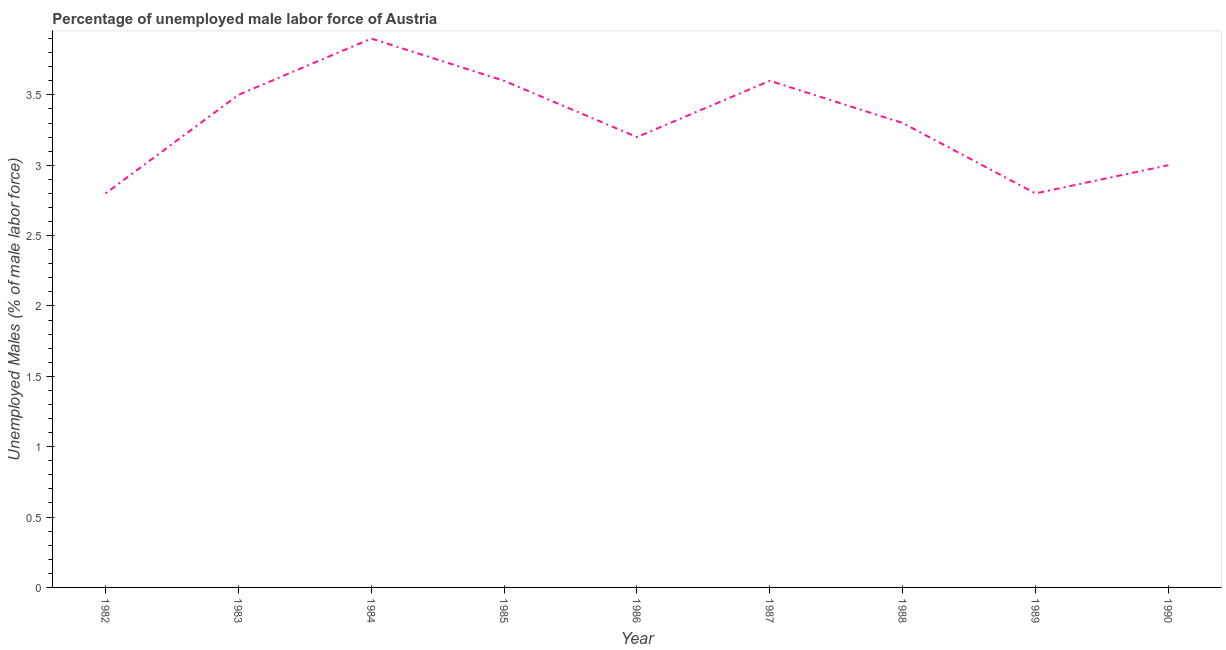What is the total unemployed male labour force in 1989?
Ensure brevity in your answer.  2.8. Across all years, what is the maximum total unemployed male labour force?
Your answer should be very brief. 3.9. Across all years, what is the minimum total unemployed male labour force?
Offer a terse response. 2.8. What is the sum of the total unemployed male labour force?
Provide a short and direct response. 29.7. What is the difference between the total unemployed male labour force in 1982 and 1986?
Give a very brief answer. -0.4. What is the average total unemployed male labour force per year?
Offer a terse response. 3.3. What is the median total unemployed male labour force?
Offer a very short reply. 3.3. In how many years, is the total unemployed male labour force greater than 0.6 %?
Ensure brevity in your answer.  9. Do a majority of the years between 1990 and 1982 (inclusive) have total unemployed male labour force greater than 1.4 %?
Keep it short and to the point. Yes. What is the ratio of the total unemployed male labour force in 1982 to that in 1983?
Provide a short and direct response. 0.8. Is the total unemployed male labour force in 1986 less than that in 1989?
Your response must be concise. No. Is the difference between the total unemployed male labour force in 1982 and 1989 greater than the difference between any two years?
Provide a short and direct response. No. What is the difference between the highest and the second highest total unemployed male labour force?
Offer a very short reply. 0.3. What is the difference between the highest and the lowest total unemployed male labour force?
Offer a very short reply. 1.1. Does the total unemployed male labour force monotonically increase over the years?
Make the answer very short. No. What is the difference between two consecutive major ticks on the Y-axis?
Provide a short and direct response. 0.5. Are the values on the major ticks of Y-axis written in scientific E-notation?
Make the answer very short. No. Does the graph contain grids?
Your answer should be compact. No. What is the title of the graph?
Provide a short and direct response. Percentage of unemployed male labor force of Austria. What is the label or title of the Y-axis?
Your answer should be very brief. Unemployed Males (% of male labor force). What is the Unemployed Males (% of male labor force) of 1982?
Keep it short and to the point. 2.8. What is the Unemployed Males (% of male labor force) in 1984?
Provide a succinct answer. 3.9. What is the Unemployed Males (% of male labor force) in 1985?
Keep it short and to the point. 3.6. What is the Unemployed Males (% of male labor force) of 1986?
Keep it short and to the point. 3.2. What is the Unemployed Males (% of male labor force) of 1987?
Provide a succinct answer. 3.6. What is the Unemployed Males (% of male labor force) in 1988?
Your response must be concise. 3.3. What is the Unemployed Males (% of male labor force) of 1989?
Make the answer very short. 2.8. What is the Unemployed Males (% of male labor force) in 1990?
Offer a terse response. 3. What is the difference between the Unemployed Males (% of male labor force) in 1982 and 1983?
Provide a succinct answer. -0.7. What is the difference between the Unemployed Males (% of male labor force) in 1982 and 1984?
Offer a terse response. -1.1. What is the difference between the Unemployed Males (% of male labor force) in 1982 and 1985?
Keep it short and to the point. -0.8. What is the difference between the Unemployed Males (% of male labor force) in 1982 and 1988?
Offer a terse response. -0.5. What is the difference between the Unemployed Males (% of male labor force) in 1982 and 1990?
Make the answer very short. -0.2. What is the difference between the Unemployed Males (% of male labor force) in 1983 and 1984?
Provide a succinct answer. -0.4. What is the difference between the Unemployed Males (% of male labor force) in 1983 and 1985?
Give a very brief answer. -0.1. What is the difference between the Unemployed Males (% of male labor force) in 1983 and 1986?
Ensure brevity in your answer.  0.3. What is the difference between the Unemployed Males (% of male labor force) in 1983 and 1987?
Provide a short and direct response. -0.1. What is the difference between the Unemployed Males (% of male labor force) in 1983 and 1988?
Provide a succinct answer. 0.2. What is the difference between the Unemployed Males (% of male labor force) in 1983 and 1989?
Your response must be concise. 0.7. What is the difference between the Unemployed Males (% of male labor force) in 1983 and 1990?
Offer a very short reply. 0.5. What is the difference between the Unemployed Males (% of male labor force) in 1984 and 1987?
Give a very brief answer. 0.3. What is the difference between the Unemployed Males (% of male labor force) in 1984 and 1988?
Ensure brevity in your answer.  0.6. What is the difference between the Unemployed Males (% of male labor force) in 1984 and 1989?
Ensure brevity in your answer.  1.1. What is the difference between the Unemployed Males (% of male labor force) in 1984 and 1990?
Provide a short and direct response. 0.9. What is the difference between the Unemployed Males (% of male labor force) in 1985 and 1986?
Make the answer very short. 0.4. What is the difference between the Unemployed Males (% of male labor force) in 1985 and 1989?
Offer a very short reply. 0.8. What is the difference between the Unemployed Males (% of male labor force) in 1986 and 1988?
Offer a very short reply. -0.1. What is the difference between the Unemployed Males (% of male labor force) in 1986 and 1989?
Provide a short and direct response. 0.4. What is the difference between the Unemployed Males (% of male labor force) in 1986 and 1990?
Keep it short and to the point. 0.2. What is the difference between the Unemployed Males (% of male labor force) in 1987 and 1988?
Make the answer very short. 0.3. What is the difference between the Unemployed Males (% of male labor force) in 1987 and 1990?
Your answer should be compact. 0.6. What is the difference between the Unemployed Males (% of male labor force) in 1988 and 1989?
Provide a succinct answer. 0.5. What is the ratio of the Unemployed Males (% of male labor force) in 1982 to that in 1984?
Offer a very short reply. 0.72. What is the ratio of the Unemployed Males (% of male labor force) in 1982 to that in 1985?
Give a very brief answer. 0.78. What is the ratio of the Unemployed Males (% of male labor force) in 1982 to that in 1987?
Offer a very short reply. 0.78. What is the ratio of the Unemployed Males (% of male labor force) in 1982 to that in 1988?
Provide a short and direct response. 0.85. What is the ratio of the Unemployed Males (% of male labor force) in 1982 to that in 1990?
Give a very brief answer. 0.93. What is the ratio of the Unemployed Males (% of male labor force) in 1983 to that in 1984?
Your answer should be very brief. 0.9. What is the ratio of the Unemployed Males (% of male labor force) in 1983 to that in 1986?
Provide a short and direct response. 1.09. What is the ratio of the Unemployed Males (% of male labor force) in 1983 to that in 1987?
Give a very brief answer. 0.97. What is the ratio of the Unemployed Males (% of male labor force) in 1983 to that in 1988?
Provide a succinct answer. 1.06. What is the ratio of the Unemployed Males (% of male labor force) in 1983 to that in 1989?
Keep it short and to the point. 1.25. What is the ratio of the Unemployed Males (% of male labor force) in 1983 to that in 1990?
Provide a succinct answer. 1.17. What is the ratio of the Unemployed Males (% of male labor force) in 1984 to that in 1985?
Your answer should be compact. 1.08. What is the ratio of the Unemployed Males (% of male labor force) in 1984 to that in 1986?
Your response must be concise. 1.22. What is the ratio of the Unemployed Males (% of male labor force) in 1984 to that in 1987?
Ensure brevity in your answer.  1.08. What is the ratio of the Unemployed Males (% of male labor force) in 1984 to that in 1988?
Your answer should be very brief. 1.18. What is the ratio of the Unemployed Males (% of male labor force) in 1984 to that in 1989?
Make the answer very short. 1.39. What is the ratio of the Unemployed Males (% of male labor force) in 1985 to that in 1986?
Keep it short and to the point. 1.12. What is the ratio of the Unemployed Males (% of male labor force) in 1985 to that in 1988?
Offer a terse response. 1.09. What is the ratio of the Unemployed Males (% of male labor force) in 1985 to that in 1989?
Your response must be concise. 1.29. What is the ratio of the Unemployed Males (% of male labor force) in 1986 to that in 1987?
Keep it short and to the point. 0.89. What is the ratio of the Unemployed Males (% of male labor force) in 1986 to that in 1988?
Keep it short and to the point. 0.97. What is the ratio of the Unemployed Males (% of male labor force) in 1986 to that in 1989?
Ensure brevity in your answer.  1.14. What is the ratio of the Unemployed Males (% of male labor force) in 1986 to that in 1990?
Offer a terse response. 1.07. What is the ratio of the Unemployed Males (% of male labor force) in 1987 to that in 1988?
Your response must be concise. 1.09. What is the ratio of the Unemployed Males (% of male labor force) in 1987 to that in 1989?
Make the answer very short. 1.29. What is the ratio of the Unemployed Males (% of male labor force) in 1987 to that in 1990?
Provide a succinct answer. 1.2. What is the ratio of the Unemployed Males (% of male labor force) in 1988 to that in 1989?
Your answer should be very brief. 1.18. What is the ratio of the Unemployed Males (% of male labor force) in 1988 to that in 1990?
Offer a very short reply. 1.1. What is the ratio of the Unemployed Males (% of male labor force) in 1989 to that in 1990?
Your answer should be very brief. 0.93. 